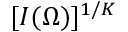Convert formula to latex. <formula><loc_0><loc_0><loc_500><loc_500>[ I ( \Omega ) ] ^ { 1 / K }</formula> 